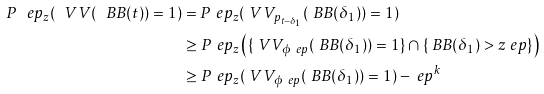<formula> <loc_0><loc_0><loc_500><loc_500>P ^ { \ } e p _ { z } ( \ V V ( \ B B ( t ) ) = 1 ) & = P ^ { \ } e p _ { z } ( \ V V _ { p _ { t - \delta _ { 1 } } } ( \ B B ( \delta _ { 1 } ) ) = 1 ) \\ & \geq P ^ { \ } e p _ { z } \left ( \{ \ V V _ { \phi ^ { \ } e p } ( \ B B ( \delta _ { 1 } ) ) = 1 \} \cap \{ \ B B ( \delta _ { 1 } ) > z _ { \ } e p \} \right ) \\ & \geq P ^ { \ } e p _ { z } ( \ V V _ { \phi ^ { \ } e p } ( \ B B ( \delta _ { 1 } ) ) = 1 ) - \ e p ^ { k }</formula> 